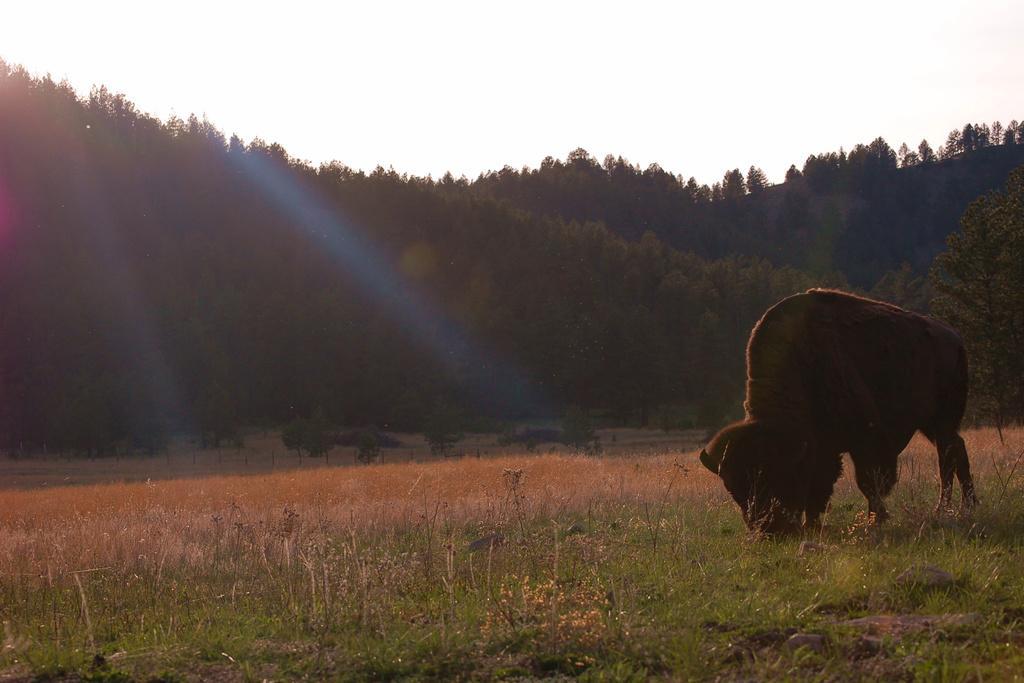In one or two sentences, can you explain what this image depicts? In this image we can see an animal on the ground. We can also see some plants, grass, a group of trees and the sky which looks cloudy. 